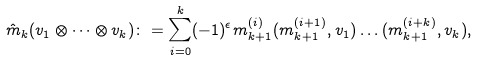<formula> <loc_0><loc_0><loc_500><loc_500>\hat { m } _ { k } ( v _ { 1 } \otimes \dots \otimes v _ { k } ) \colon = \sum _ { i = 0 } ^ { k } ( - 1 ) ^ { \epsilon } m ^ { ( i ) } _ { k + 1 } ( m ^ { ( i + 1 ) } _ { k + 1 } , v _ { 1 } ) \dots ( m ^ { ( i + k ) } _ { k + 1 } , v _ { k } ) ,</formula> 